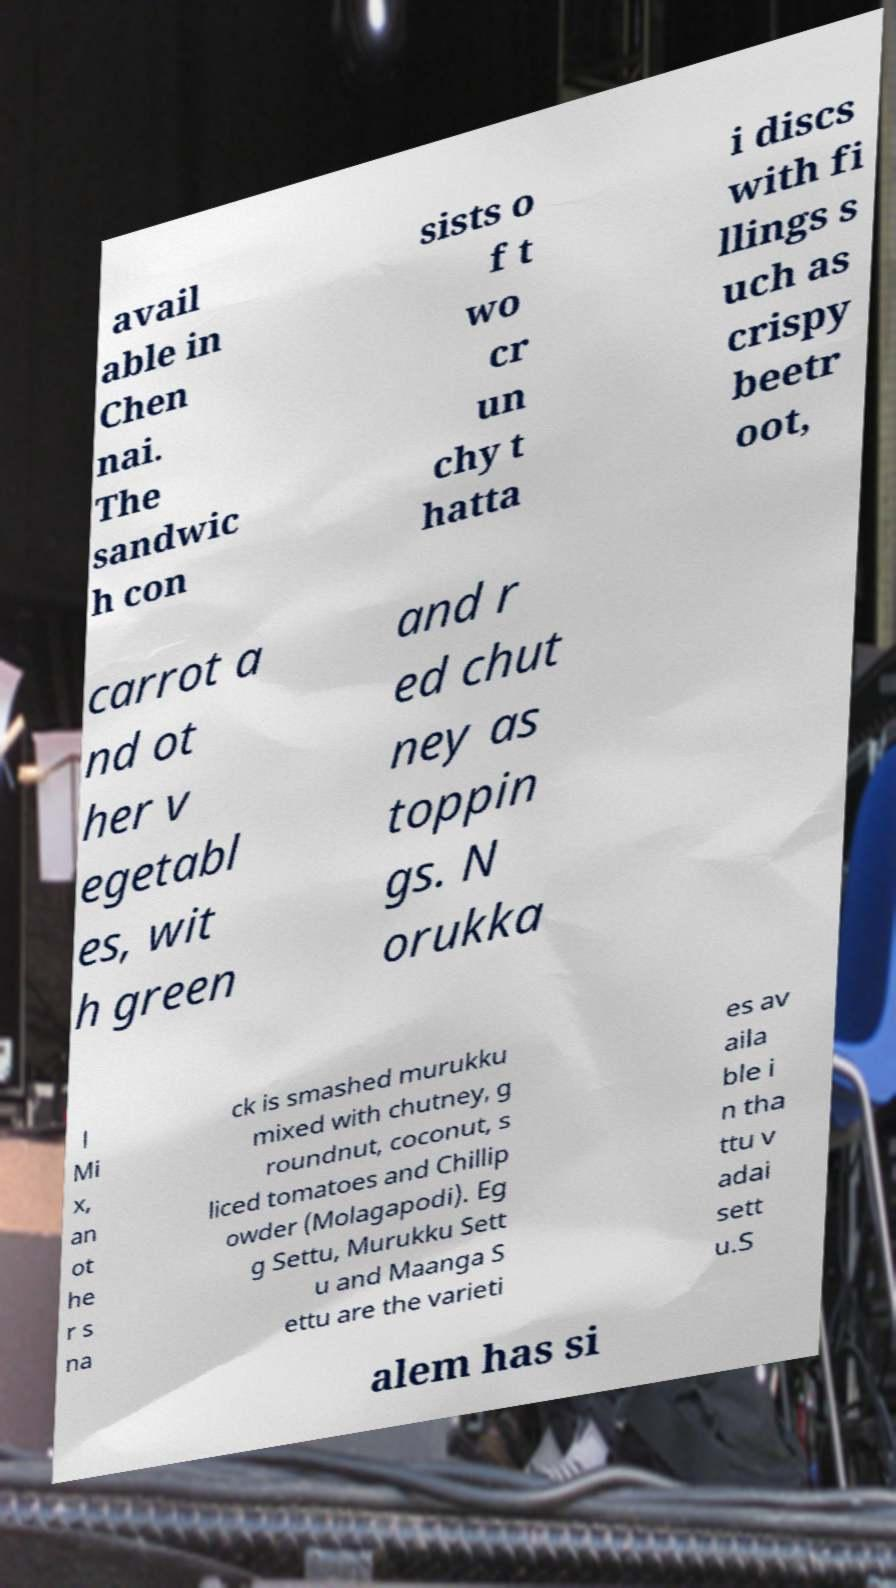There's text embedded in this image that I need extracted. Can you transcribe it verbatim? avail able in Chen nai. The sandwic h con sists o f t wo cr un chy t hatta i discs with fi llings s uch as crispy beetr oot, carrot a nd ot her v egetabl es, wit h green and r ed chut ney as toppin gs. N orukka l Mi x, an ot he r s na ck is smashed murukku mixed with chutney, g roundnut, coconut, s liced tomatoes and Chillip owder (Molagapodi). Eg g Settu, Murukku Sett u and Maanga S ettu are the varieti es av aila ble i n tha ttu v adai sett u.S alem has si 